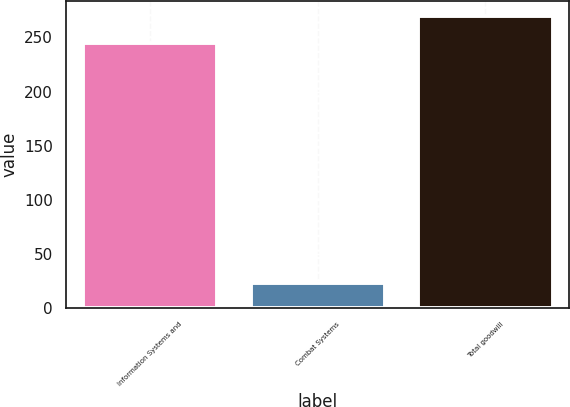Convert chart to OTSL. <chart><loc_0><loc_0><loc_500><loc_500><bar_chart><fcel>Information Systems and<fcel>Combat Systems<fcel>Total goodwill<nl><fcel>245<fcel>23<fcel>270<nl></chart> 